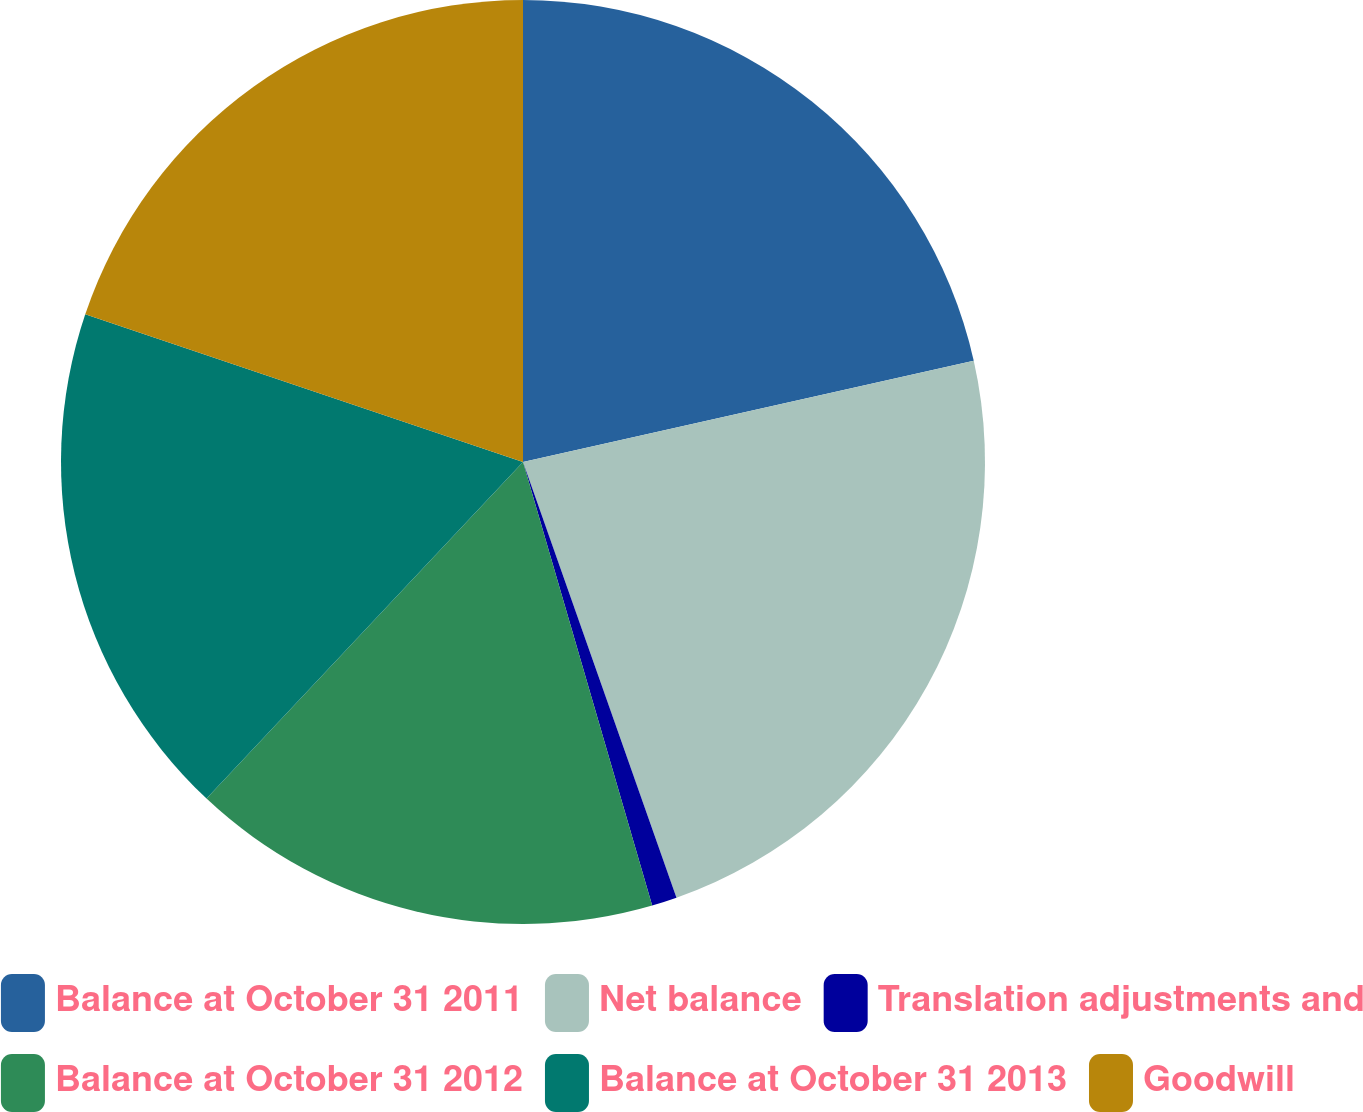<chart> <loc_0><loc_0><loc_500><loc_500><pie_chart><fcel>Balance at October 31 2011<fcel>Net balance<fcel>Translation adjustments and<fcel>Balance at October 31 2012<fcel>Balance at October 31 2013<fcel>Goodwill<nl><fcel>21.48%<fcel>23.13%<fcel>0.88%<fcel>16.52%<fcel>18.17%<fcel>19.82%<nl></chart> 